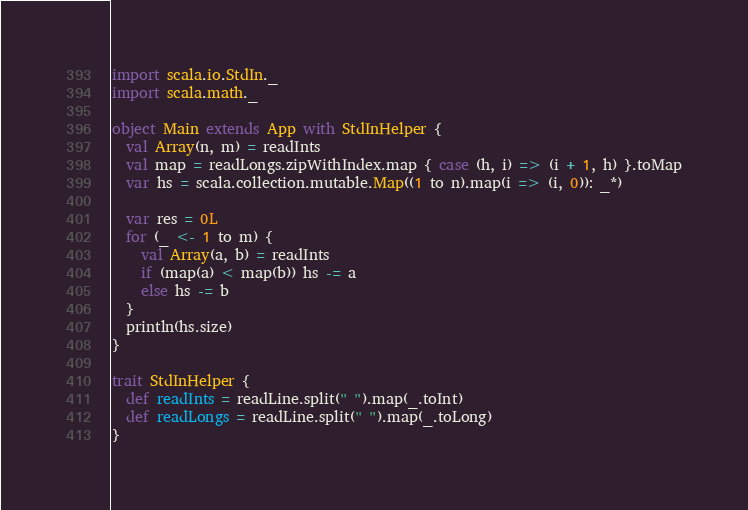Convert code to text. <code><loc_0><loc_0><loc_500><loc_500><_Scala_>import scala.io.StdIn._
import scala.math._

object Main extends App with StdInHelper {
  val Array(n, m) = readInts
  val map = readLongs.zipWithIndex.map { case (h, i) => (i + 1, h) }.toMap
  var hs = scala.collection.mutable.Map((1 to n).map(i => (i, 0)): _*)

  var res = 0L
  for (_ <- 1 to m) {
    val Array(a, b) = readInts
    if (map(a) < map(b)) hs -= a
    else hs -= b
  }
  println(hs.size)
}

trait StdInHelper {
  def readInts = readLine.split(" ").map(_.toInt)
  def readLongs = readLine.split(" ").map(_.toLong)
}
</code> 